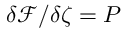<formula> <loc_0><loc_0><loc_500><loc_500>\delta \mathcal { F } / \delta \zeta = P</formula> 